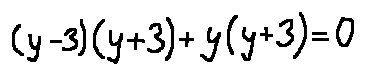Convert formula to latex. <formula><loc_0><loc_0><loc_500><loc_500>( y - 3 ) ( y + 3 ) + y ( y + 3 ) = 0</formula> 